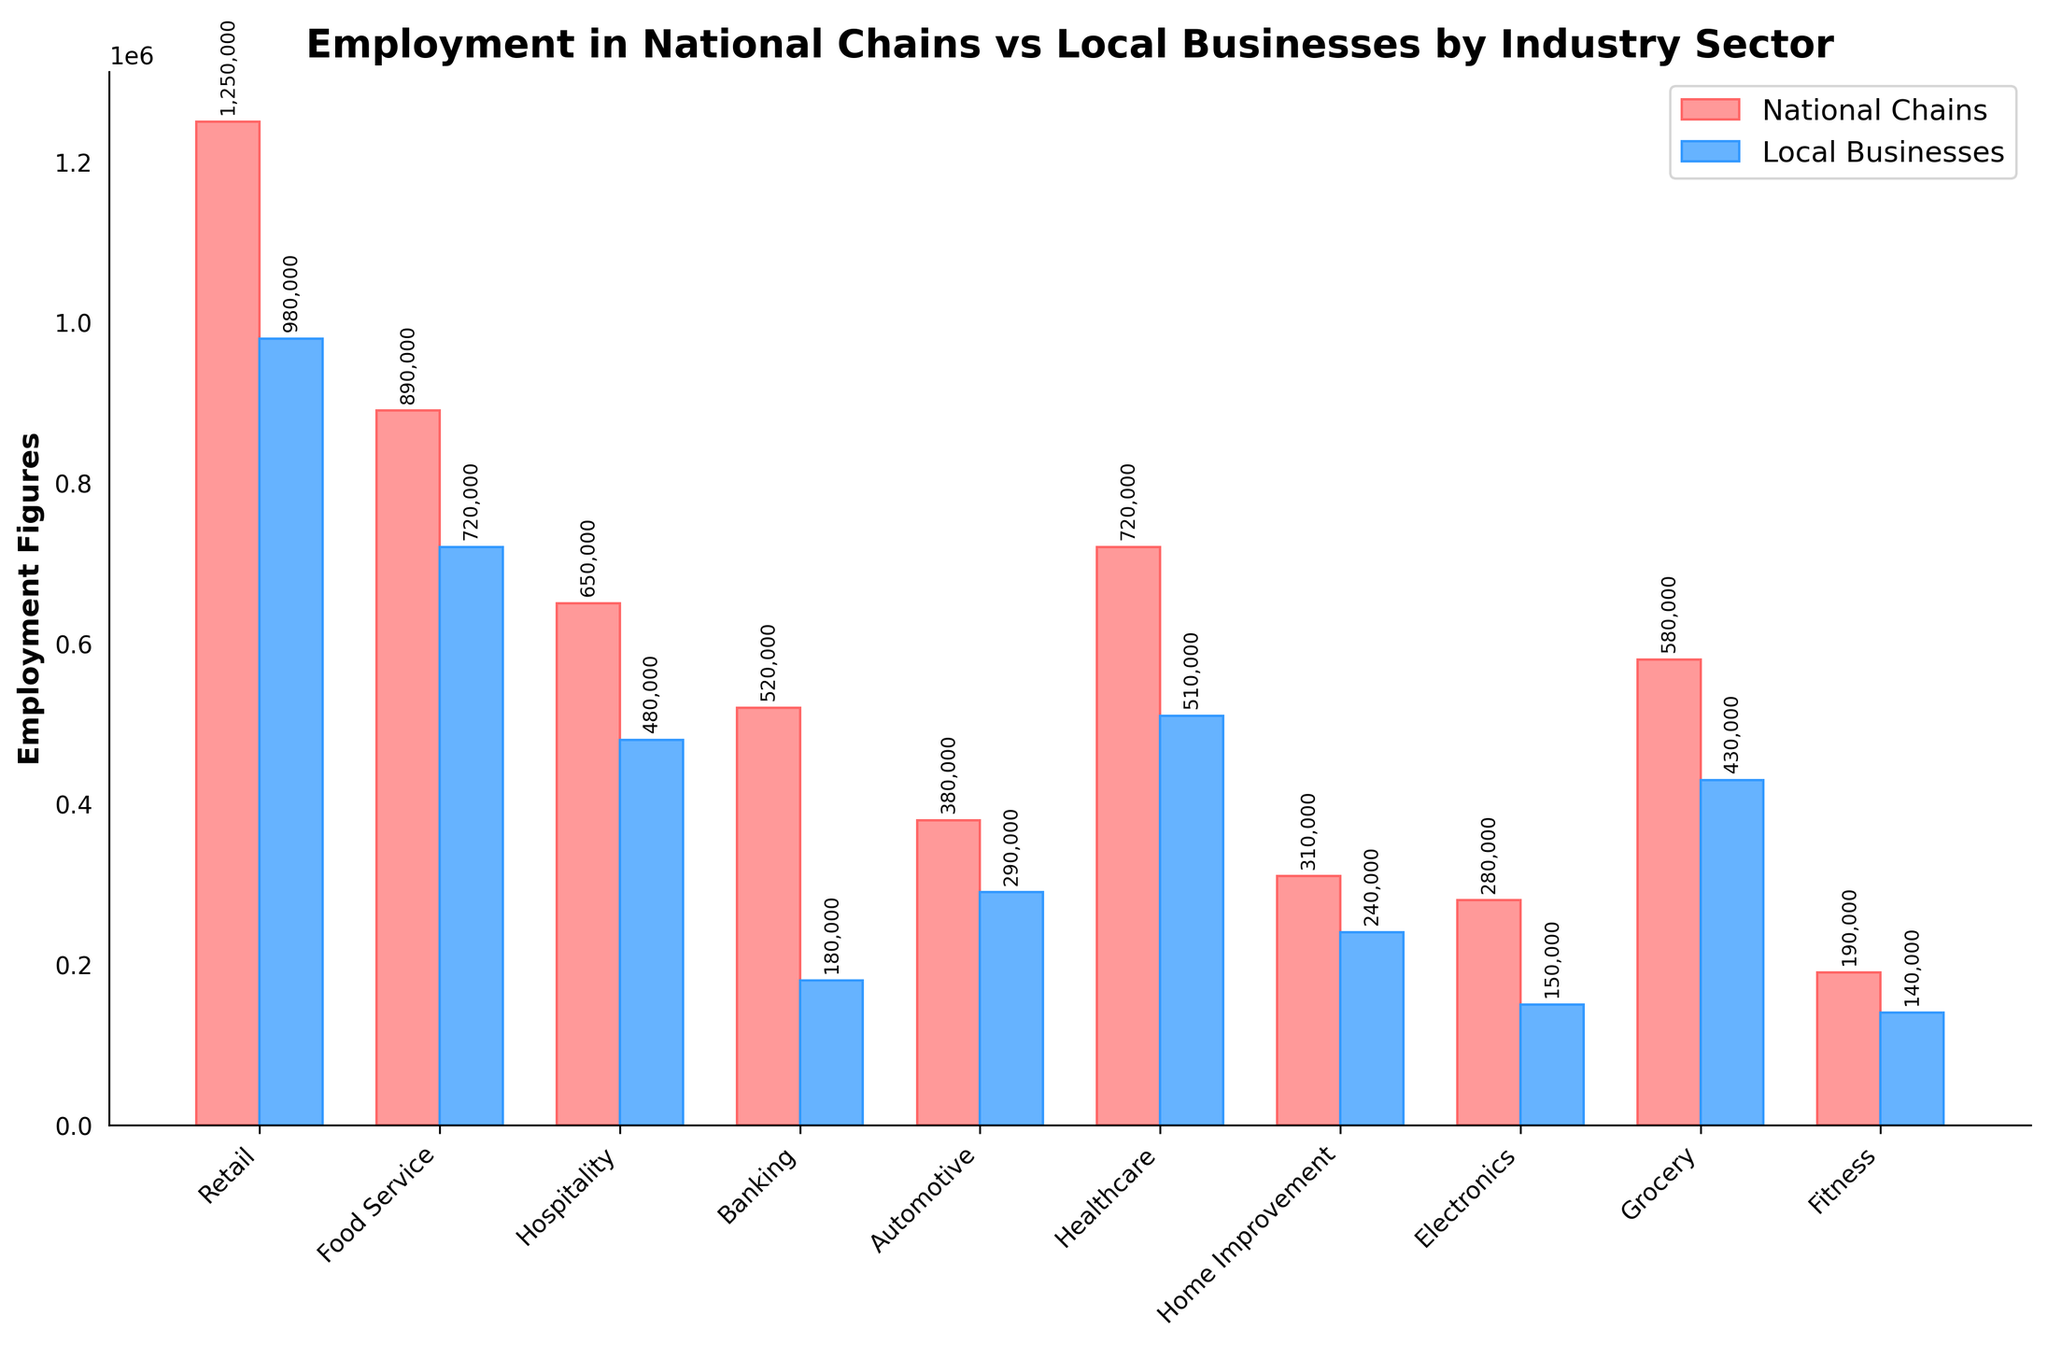Which industry sector has the highest employment in national chains? Compare the heights of the bars representing national chains and find the tallest one. The Retail sector has the tallest bar.
Answer: Retail Which industry sector has the least employment in local businesses? Compare the heights of the bars representing local businesses and find the shortest one. The Electronics sector has the shortest bar.
Answer: Electronics How many more people are employed in national chains compared to local businesses in the Banking sector? Refer to the heights of the bars for Banking sector: National Chains (520,000) - Local Businesses (180,000) = 340,000.
Answer: 340,000 What is the combined employment for national chains and local businesses in the Food Service sector? Add the heights of the bars for Food Service sector: National Chains (890,000) + Local Businesses (720,000) = 1,610,000.
Answer: 1,610,000 Which industry sector has the smallest difference in employment between national chains and local businesses? Calculate the differences for each sector, then find the smallest one. Home Improvement: National Chains (310,000) - Local Businesses (240,000) = 70,000.
Answer: Home Improvement In how many industry sectors do national chains employ more than double the number of people employed by local businesses? Check where National Chains employment is more than twice that of Local Businesses. The Healthcare, Electronics, and Banking sectors meet this criterion (3 sectors).
Answer: 3 sectors What is the total employment across all sectors for local businesses? Sum the heights of all local businesses bars: 980,000 + 720,000 + 480,000 + 180,000 + 290,000 + 510,000 + 240,000 + 150,000 + 430,000 + 140,000 = 4,120,000.
Answer: 4,120,000 Which sector has the most equal employment figures between national chains and local businesses? Find the sector where the heights of the bars are most similar. The Home Improvement sector has the closest values with a difference of 70,000.
Answer: Home Improvement What is the average employment for national chains across all sectors? Sum the heights of all national chains bars and divide by the number of sectors: (1,250,000 + 890,000 + 650,000 + 520,000 + 380,000 + 720,000 + 310,000 + 280,000 + 580,000 + 190,000) / 10 = 577,000.
Answer: 577,000 